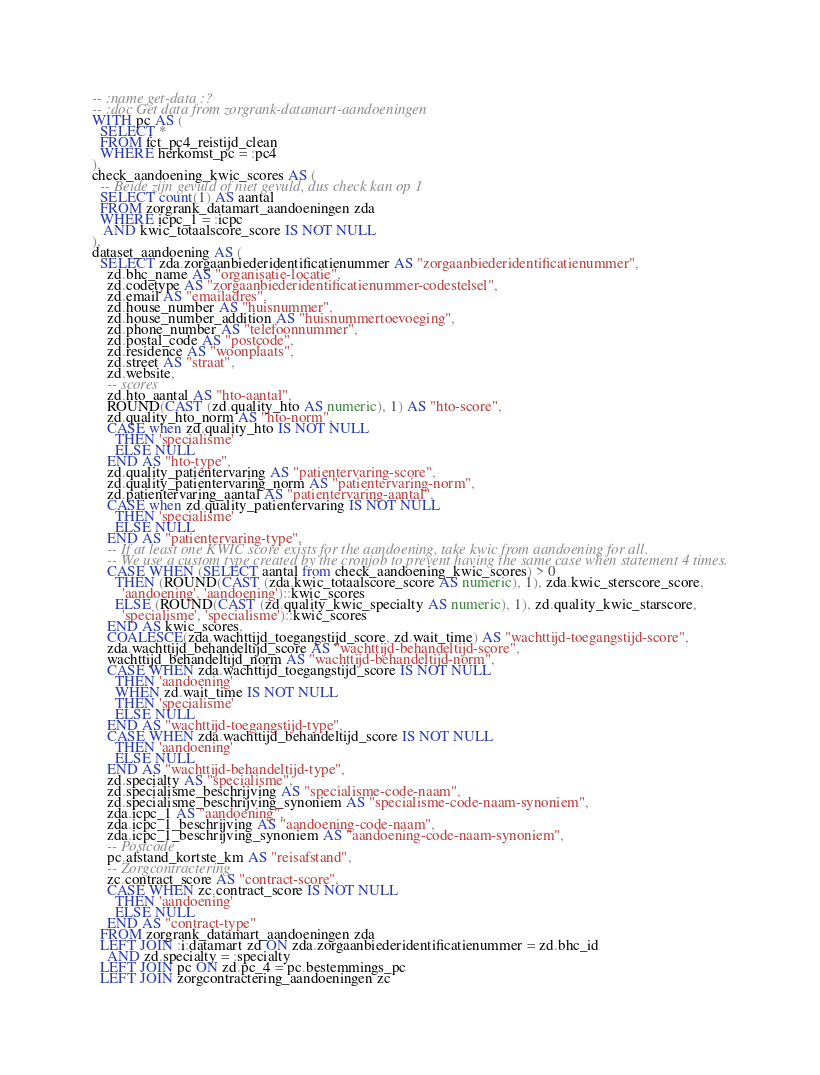Convert code to text. <code><loc_0><loc_0><loc_500><loc_500><_SQL_>-- :name get-data :?
-- :doc Get data from zorgrank-datamart-aandoeningen
WITH pc AS (
  SELECT *
  FROM fct_pc4_reistijd_clean
  WHERE herkomst_pc = :pc4
),
check_aandoening_kwic_scores AS (
  -- Beide zijn gevuld of niet gevuld, dus check kan op 1
  SELECT count(1) AS aantal
  FROM zorgrank_datamart_aandoeningen zda
  WHERE icpc_1 = :icpc
   AND kwic_totaalscore_score IS NOT NULL
),
dataset_aandoening AS (
  SELECT zda.zorgaanbiederidentificatienummer AS "zorgaanbiederidentificatienummer",
    zd.bhc_name AS "organisatie-locatie",
    zd.codetype AS "zorgaanbiederidentificatienummer-codestelsel",
    zd.email AS "emailadres",
    zd.house_number AS "huisnummer",
    zd.house_number_addition AS "huisnummertoevoeging",
    zd.phone_number AS "telefoonnummer",
    zd.postal_code AS "postcode",
    zd.residence AS "woonplaats",
    zd.street AS "straat",
    zd.website,
    -- scores
    zd.hto_aantal AS "hto-aantal",
    ROUND(CAST (zd.quality_hto AS numeric), 1) AS "hto-score",
    zd.quality_hto_norm AS "hto-norm",
    CASE when zd.quality_hto IS NOT NULL
      THEN 'specialisme'
      ELSE NULL
    END AS "hto-type",
    zd.quality_patientervaring AS "patientervaring-score",
    zd.quality_patientervaring_norm AS "patientervaring-norm",
    zd.patientervaring_aantal AS "patientervaring-aantal",
    CASE when zd.quality_patientervaring IS NOT NULL
      THEN 'specialisme'
      ELSE NULL
    END AS "patientervaring-type",
    -- If at least one KWIC score exists for the aandoening, take kwic from aandoening for all.
    -- We use a custom type created by the cronjob to prevent having the same case when statement 4 times.
    CASE WHEN (SELECT aantal from check_aandoening_kwic_scores) > 0
      THEN (ROUND(CAST (zda.kwic_totaalscore_score AS numeric), 1), zda.kwic_sterscore_score,
        'aandoening', 'aandoening')::kwic_scores
      ELSE (ROUND(CAST (zd.quality_kwic_specialty AS numeric), 1), zd.quality_kwic_starscore,
        'specialisme', 'specialisme')::kwic_scores
    END AS kwic_scores,
    COALESCE(zda.wachttijd_toegangstijd_score, zd.wait_time) AS "wachttijd-toegangstijd-score",
    zda.wachttijd_behandeltijd_score AS "wachttijd-behandeltijd-score",
    wachttijd_behandeltijd_norm AS "wachttijd-behandeltijd-norm",
    CASE WHEN zda.wachttijd_toegangstijd_score IS NOT NULL
      THEN 'aandoening'
      WHEN zd.wait_time IS NOT NULL
      THEN 'specialisme'
      ELSE NULL
    END AS "wachttijd-toegangstijd-type",
    CASE WHEN zda.wachttijd_behandeltijd_score IS NOT NULL
      THEN 'aandoening'
      ELSE NULL
    END AS "wachttijd-behandeltijd-type",
    zd.specialty AS "specialisme",
    zd.specialisme_beschrijving AS "specialisme-code-naam",
    zd.specialisme_beschrijving_synoniem AS "specialisme-code-naam-synoniem",
    zda.icpc_1 AS "aandoening",
    zda.icpc_1_beschrijving AS "aandoening-code-naam",
    zda.icpc_1_beschrijving_synoniem AS "aandoening-code-naam-synoniem",
    -- Postcode
    pc.afstand_kortste_km AS "reisafstand",
    -- Zorgcontractering
    zc.contract_score AS "contract-score",
    CASE WHEN zc.contract_score IS NOT NULL
      THEN 'aandoening'
      ELSE NULL
    END AS "contract-type"
  FROM zorgrank_datamart_aandoeningen zda
  LEFT JOIN :i:datamart zd ON zda.zorgaanbiederidentificatienummer = zd.bhc_id
    AND zd.specialty = :specialty
  LEFT JOIN pc ON zd.pc_4 = pc.bestemmings_pc
  LEFT JOIN zorgcontractering_aandoeningen zc</code> 